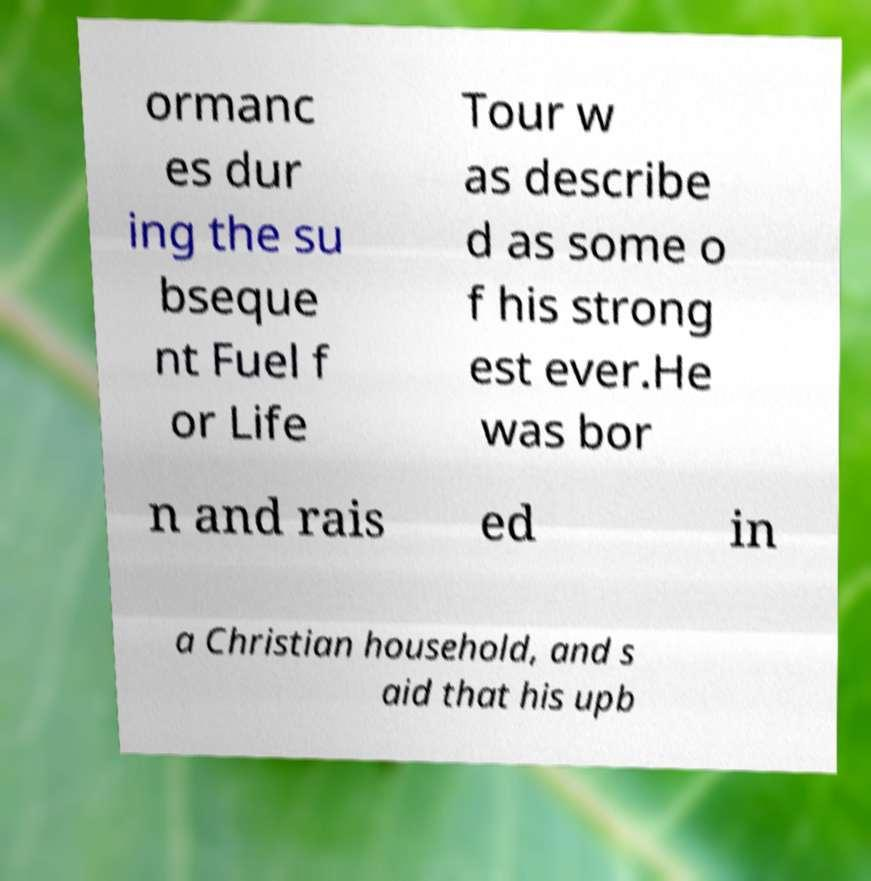I need the written content from this picture converted into text. Can you do that? ormanc es dur ing the su bseque nt Fuel f or Life Tour w as describe d as some o f his strong est ever.He was bor n and rais ed in a Christian household, and s aid that his upb 